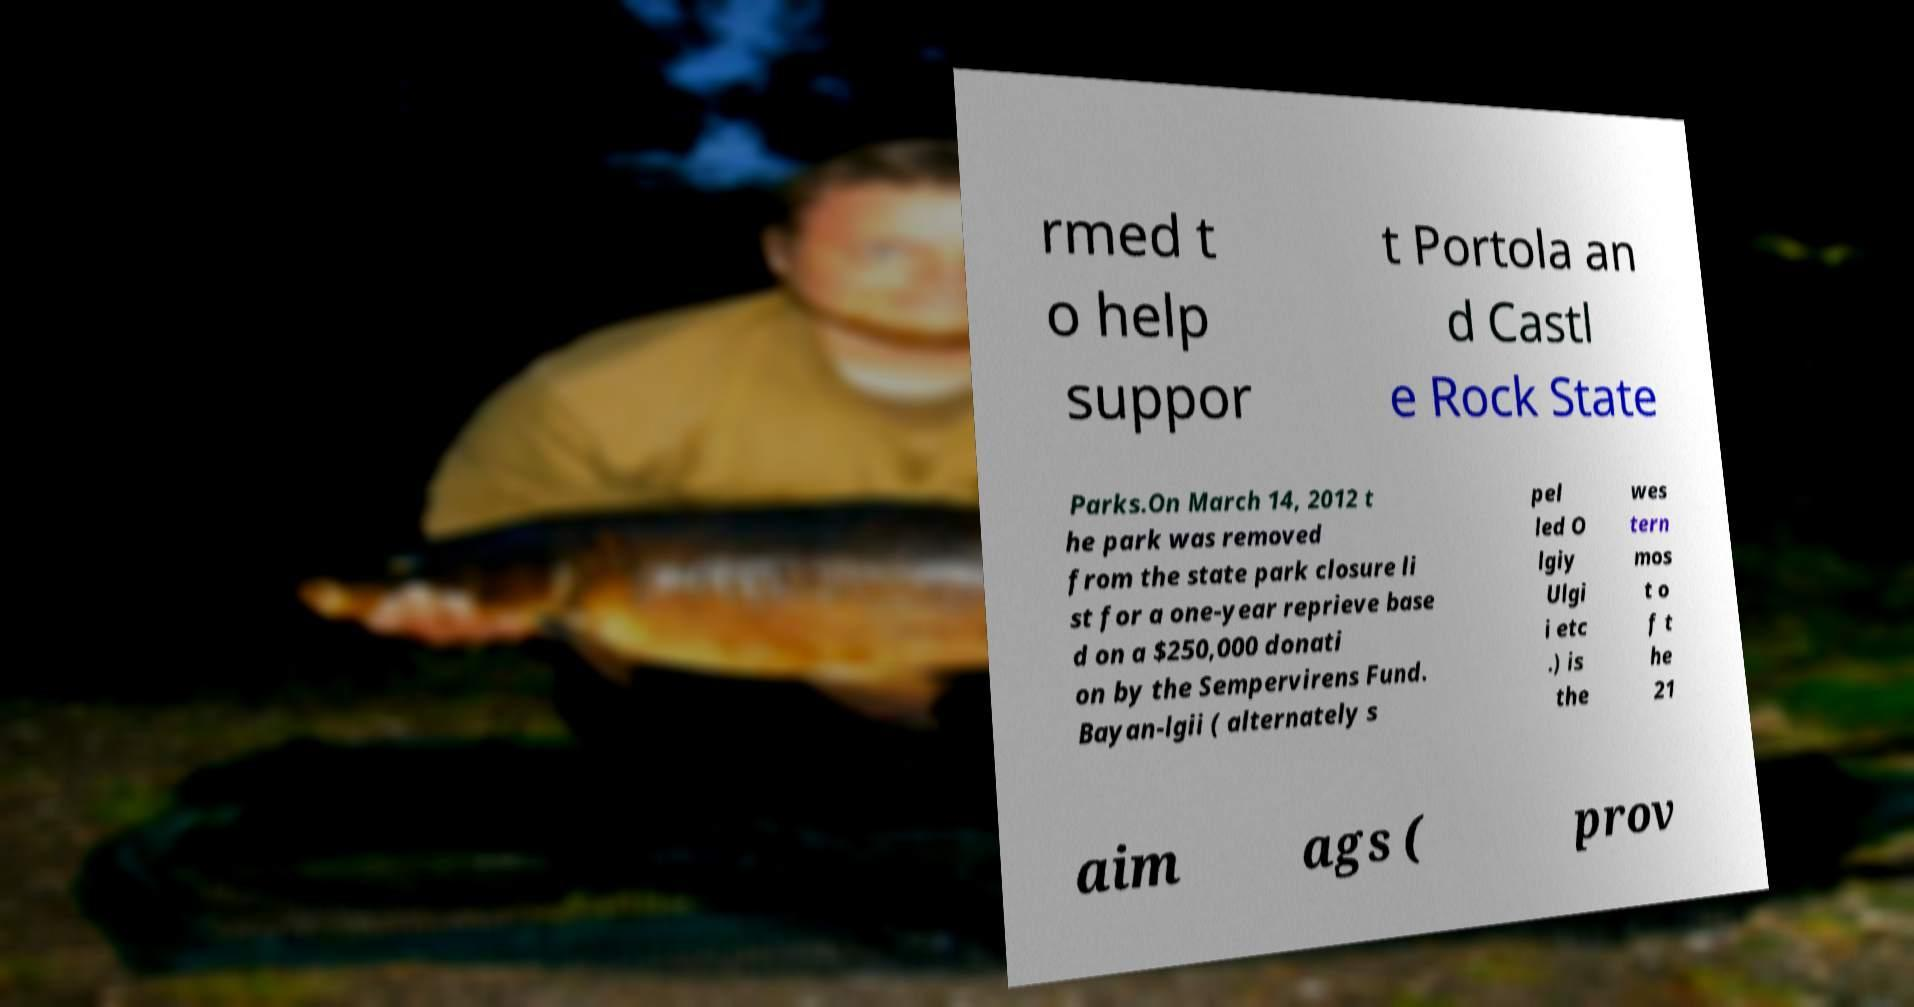For documentation purposes, I need the text within this image transcribed. Could you provide that? rmed t o help suppor t Portola an d Castl e Rock State Parks.On March 14, 2012 t he park was removed from the state park closure li st for a one-year reprieve base d on a $250,000 donati on by the Sempervirens Fund. Bayan-lgii ( alternately s pel led O lgiy Ulgi i etc .) is the wes tern mos t o f t he 21 aim ags ( prov 